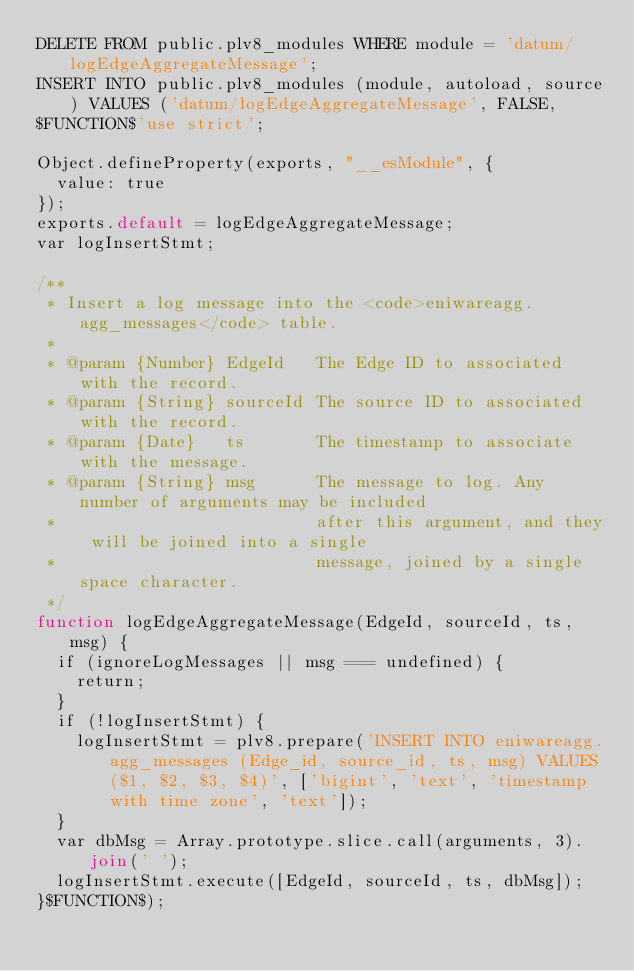Convert code to text. <code><loc_0><loc_0><loc_500><loc_500><_SQL_>DELETE FROM public.plv8_modules WHERE module = 'datum/logEdgeAggregateMessage';
INSERT INTO public.plv8_modules (module, autoload, source) VALUES ('datum/logEdgeAggregateMessage', FALSE,
$FUNCTION$'use strict';

Object.defineProperty(exports, "__esModule", {
	value: true
});
exports.default = logEdgeAggregateMessage;
var logInsertStmt;

/**
 * Insert a log message into the <code>eniwareagg.agg_messages</code> table.
 *
 * @param {Number} EdgeId   The Edge ID to associated with the record.
 * @param {String} sourceId The source ID to associated with the record.
 * @param {Date}   ts       The timestamp to associate with the message.
 * @param {String} msg      The message to log. Any number of arguments may be included
 *                          after this argument, and they will be joined into a single
 *                          message, joined by a single space character.
 */
function logEdgeAggregateMessage(EdgeId, sourceId, ts, msg) {
	if (ignoreLogMessages || msg === undefined) {
		return;
	}
	if (!logInsertStmt) {
		logInsertStmt = plv8.prepare('INSERT INTO eniwareagg.agg_messages (Edge_id, source_id, ts, msg) VALUES ($1, $2, $3, $4)', ['bigint', 'text', 'timestamp with time zone', 'text']);
	}
	var dbMsg = Array.prototype.slice.call(arguments, 3).join(' ');
	logInsertStmt.execute([EdgeId, sourceId, ts, dbMsg]);
}$FUNCTION$);</code> 